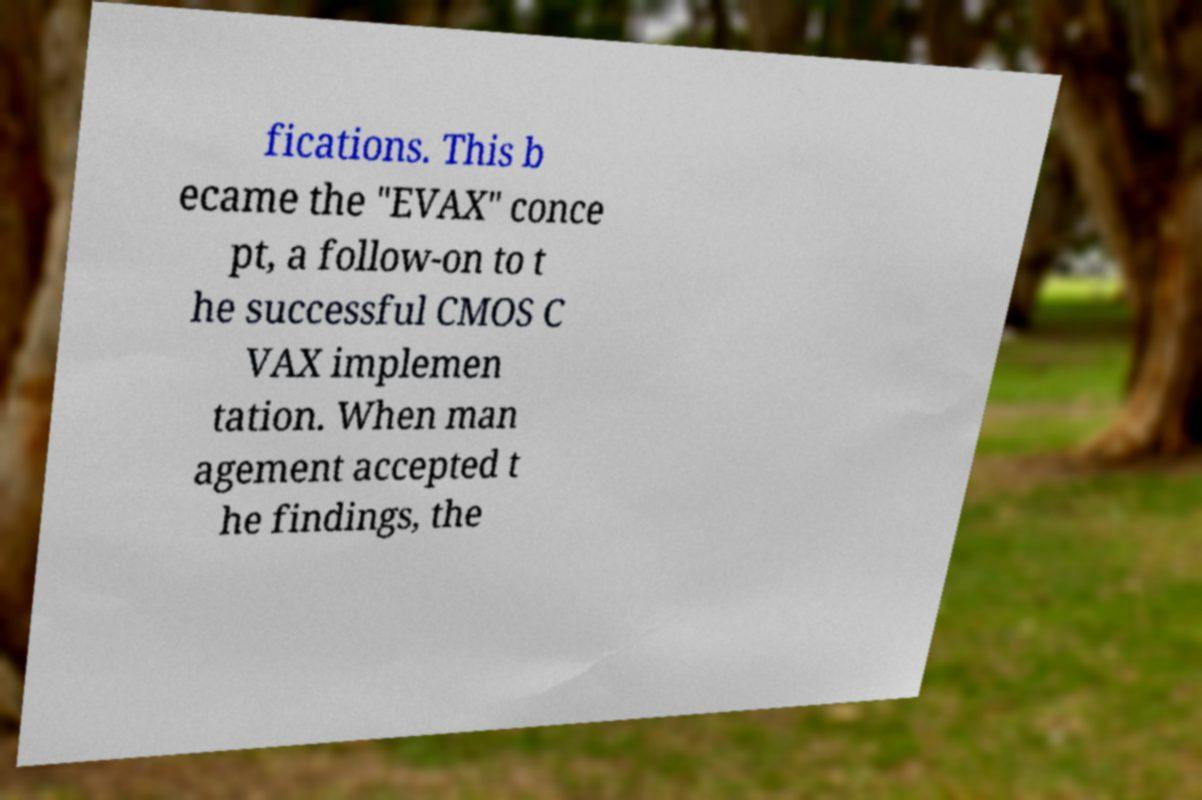Can you accurately transcribe the text from the provided image for me? fications. This b ecame the "EVAX" conce pt, a follow-on to t he successful CMOS C VAX implemen tation. When man agement accepted t he findings, the 